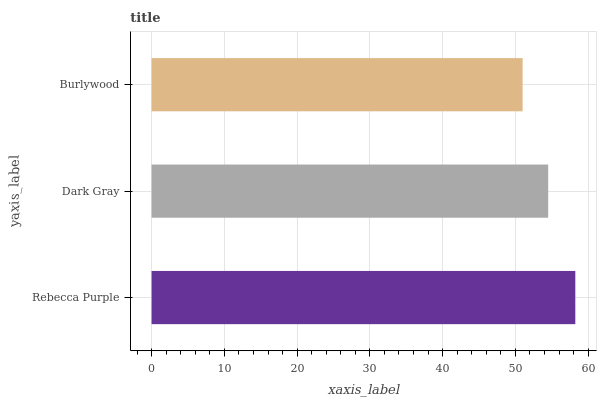Is Burlywood the minimum?
Answer yes or no. Yes. Is Rebecca Purple the maximum?
Answer yes or no. Yes. Is Dark Gray the minimum?
Answer yes or no. No. Is Dark Gray the maximum?
Answer yes or no. No. Is Rebecca Purple greater than Dark Gray?
Answer yes or no. Yes. Is Dark Gray less than Rebecca Purple?
Answer yes or no. Yes. Is Dark Gray greater than Rebecca Purple?
Answer yes or no. No. Is Rebecca Purple less than Dark Gray?
Answer yes or no. No. Is Dark Gray the high median?
Answer yes or no. Yes. Is Dark Gray the low median?
Answer yes or no. Yes. Is Rebecca Purple the high median?
Answer yes or no. No. Is Burlywood the low median?
Answer yes or no. No. 